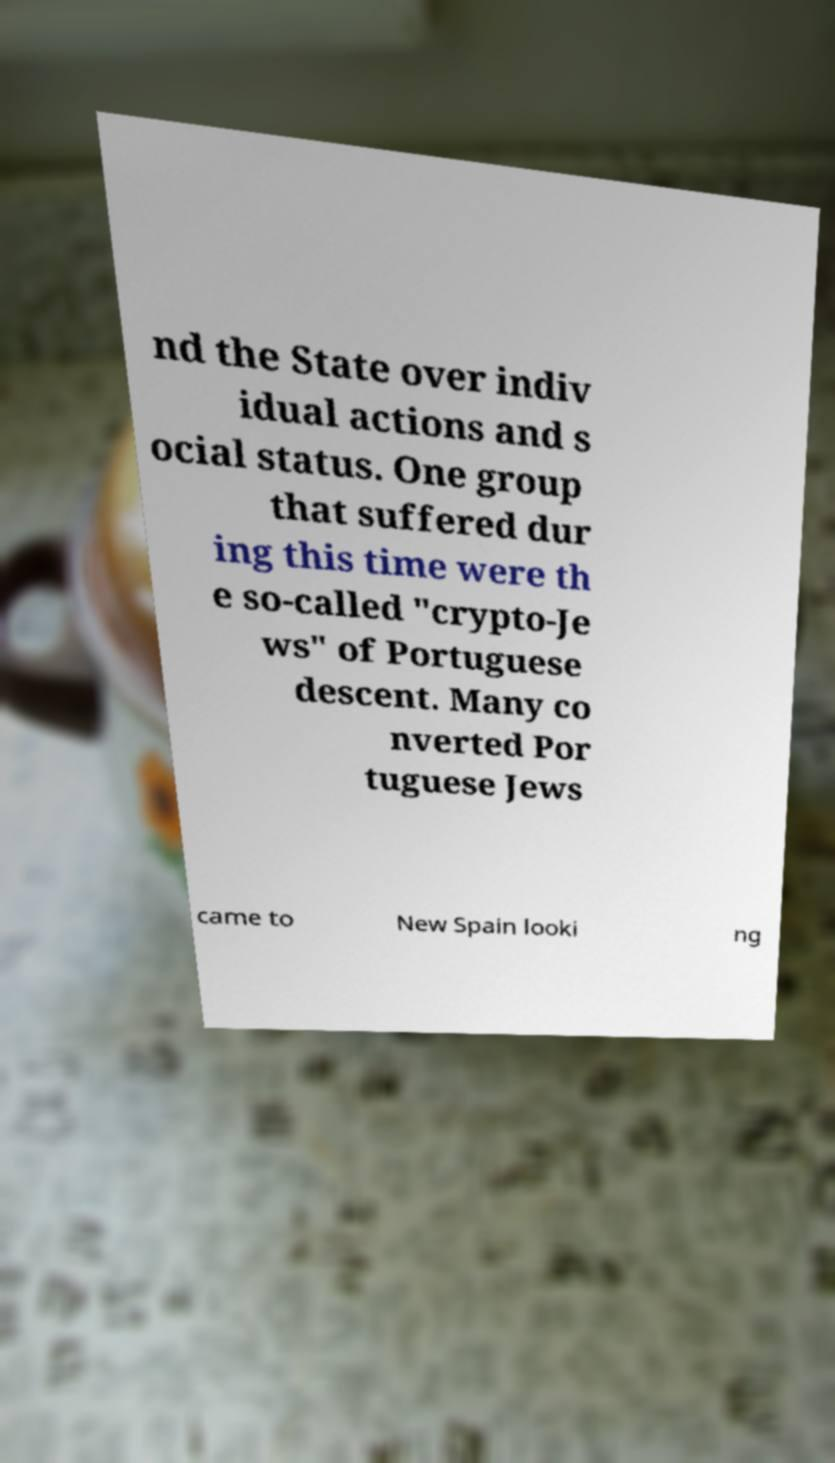For documentation purposes, I need the text within this image transcribed. Could you provide that? nd the State over indiv idual actions and s ocial status. One group that suffered dur ing this time were th e so-called "crypto-Je ws" of Portuguese descent. Many co nverted Por tuguese Jews came to New Spain looki ng 